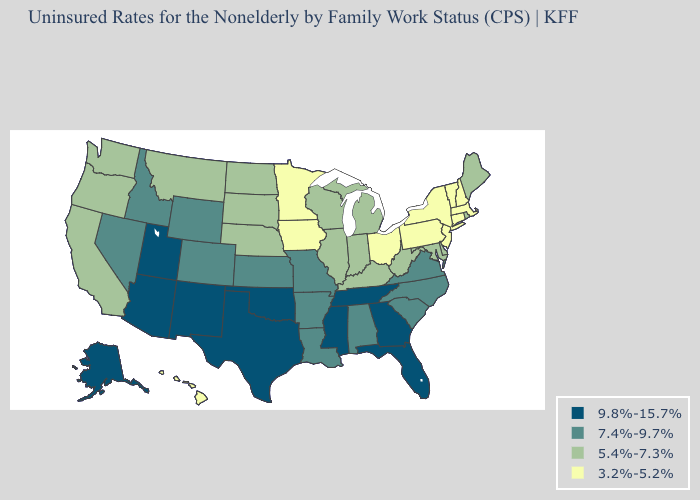Name the states that have a value in the range 7.4%-9.7%?
Quick response, please. Alabama, Arkansas, Colorado, Idaho, Kansas, Louisiana, Missouri, Nevada, North Carolina, South Carolina, Virginia, Wyoming. Name the states that have a value in the range 9.8%-15.7%?
Give a very brief answer. Alaska, Arizona, Florida, Georgia, Mississippi, New Mexico, Oklahoma, Tennessee, Texas, Utah. How many symbols are there in the legend?
Give a very brief answer. 4. Name the states that have a value in the range 5.4%-7.3%?
Keep it brief. California, Delaware, Illinois, Indiana, Kentucky, Maine, Maryland, Michigan, Montana, Nebraska, North Dakota, Oregon, Rhode Island, South Dakota, Washington, West Virginia, Wisconsin. Name the states that have a value in the range 3.2%-5.2%?
Write a very short answer. Connecticut, Hawaii, Iowa, Massachusetts, Minnesota, New Hampshire, New Jersey, New York, Ohio, Pennsylvania, Vermont. Does the first symbol in the legend represent the smallest category?
Short answer required. No. What is the value of Indiana?
Keep it brief. 5.4%-7.3%. Among the states that border Iowa , which have the lowest value?
Short answer required. Minnesota. Does the first symbol in the legend represent the smallest category?
Quick response, please. No. Does Missouri have the highest value in the MidWest?
Be succinct. Yes. What is the value of Arizona?
Quick response, please. 9.8%-15.7%. What is the value of Virginia?
Be succinct. 7.4%-9.7%. What is the value of Georgia?
Keep it brief. 9.8%-15.7%. Among the states that border North Dakota , which have the lowest value?
Quick response, please. Minnesota. What is the highest value in states that border Texas?
Give a very brief answer. 9.8%-15.7%. 